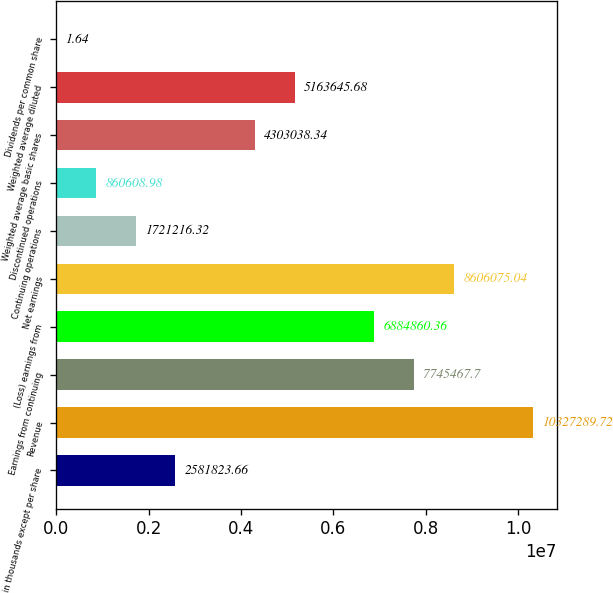Convert chart. <chart><loc_0><loc_0><loc_500><loc_500><bar_chart><fcel>in thousands except per share<fcel>Revenue<fcel>Earnings from continuing<fcel>(Loss) earnings from<fcel>Net earnings<fcel>Continuing operations<fcel>Discontinued operations<fcel>Weighted average basic shares<fcel>Weighted average diluted<fcel>Dividends per common share<nl><fcel>2.58182e+06<fcel>1.03273e+07<fcel>7.74547e+06<fcel>6.88486e+06<fcel>8.60608e+06<fcel>1.72122e+06<fcel>860609<fcel>4.30304e+06<fcel>5.16365e+06<fcel>1.64<nl></chart> 